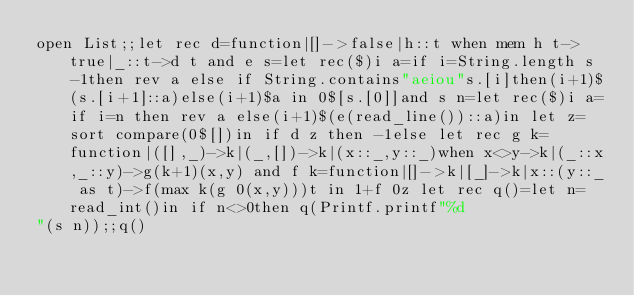Convert code to text. <code><loc_0><loc_0><loc_500><loc_500><_OCaml_>open List;;let rec d=function|[]->false|h::t when mem h t->true|_::t->d t and e s=let rec($)i a=if i=String.length s-1then rev a else if String.contains"aeiou"s.[i]then(i+1)$(s.[i+1]::a)else(i+1)$a in 0$[s.[0]]and s n=let rec($)i a=if i=n then rev a else(i+1)$(e(read_line())::a)in let z=sort compare(0$[])in if d z then -1else let rec g k=function|([],_)->k|(_,[])->k|(x::_,y::_)when x<>y->k|(_::x,_::y)->g(k+1)(x,y) and f k=function|[]->k|[_]->k|x::(y::_ as t)->f(max k(g 0(x,y)))t in 1+f 0z let rec q()=let n=read_int()in if n<>0then q(Printf.printf"%d
"(s n));;q()</code> 